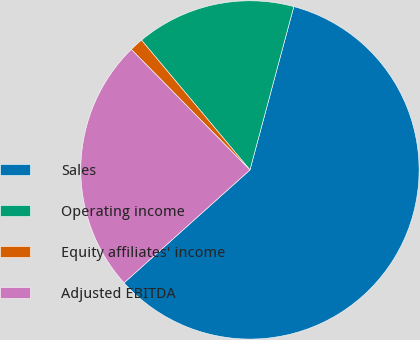Convert chart to OTSL. <chart><loc_0><loc_0><loc_500><loc_500><pie_chart><fcel>Sales<fcel>Operating income<fcel>Equity affiliates' income<fcel>Adjusted EBITDA<nl><fcel>59.19%<fcel>15.25%<fcel>1.3%<fcel>24.26%<nl></chart> 